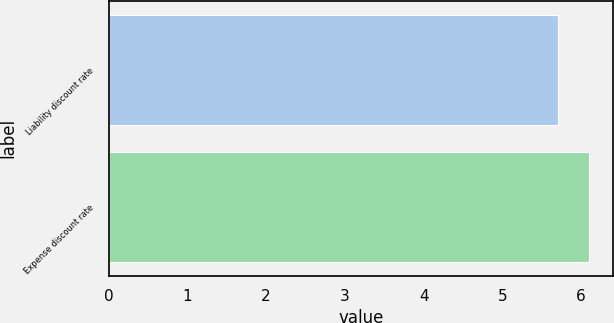Convert chart to OTSL. <chart><loc_0><loc_0><loc_500><loc_500><bar_chart><fcel>Liability discount rate<fcel>Expense discount rate<nl><fcel>5.7<fcel>6.1<nl></chart> 